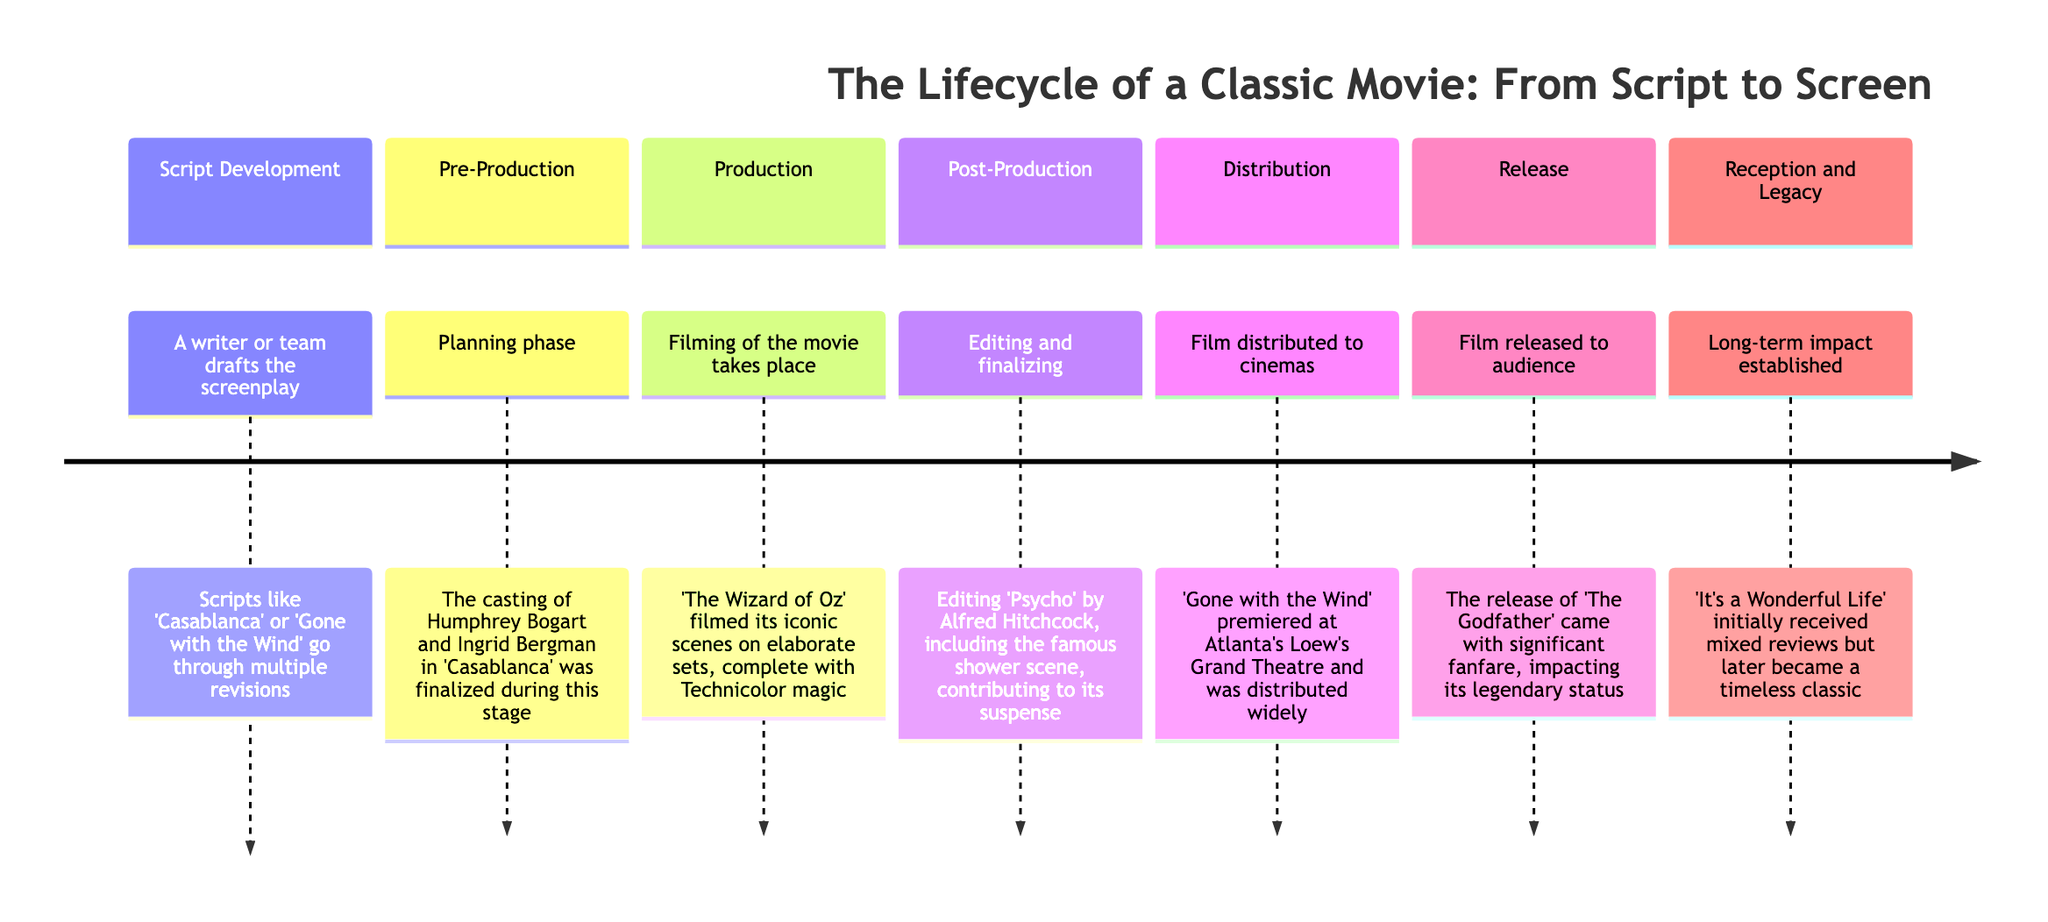What is the first stage of the classic movie lifecycle? The timeline begins with the "Script Development" stage, indicating it is the first step in creating a classic movie.
Answer: Script Development What phase involves hiring cast and crew? The "Pre-Production" stage is explicitly described as the planning phase where the cast and crew are hired, highlighting its importance in the lifecycle.
Answer: Pre-Production What movie is mentioned during the Production stage? The diagram specifically references "The Wizard of Oz" within the Production section, indicating its significance during filming.
Answer: The Wizard of Oz Which classic film had mixed initial reviews but became timeless? According to the Reception and Legacy stage, "'It's a Wonderful Life'" is highlighted as having initially received mixed reviews before achieving classic status.
Answer: It's a Wonderful Life How many stages are outlined in the movie lifecycle? By counting the sections in the timeline, there are a total of seven stages listed in the lifecycle of a classic movie.
Answer: 7 What immediate step follows the Post-Production stage? The timeline clearly states that the "Distribution" stage immediately follows "Post-Production," showing the chronological order of the filmmaking process.
Answer: Distribution In which stage was the casting of Humphrey Bogart finalized? The timeline indicates that the casting of Humphrey Bogart occurred during the "Pre-Production" phase, signifying its role in the lifecycle.
Answer: Pre-Production What is added during Post-Production to finalize the film? The explanation in the "Post-Production" stage mentions that editing, music, and sound effects are added to finalize a film during this phase.
Answer: Music and sound effects What significant event happens during the Release stage? The "Release" stage is highlighted as involving the film being introduced to the audience, often accompanied by marketing campaigns and premieres.
Answer: Marketing campaigns and premieres What was significant about the premiere of "Gone with the Wind"? The "Distribution" section specifies that "Gone with the Wind" premiered at Atlanta’s Loew's Grand Theatre, indicating its historical significance in the timeline.
Answer: Premiere at Atlanta’s Loew's Grand Theatre 